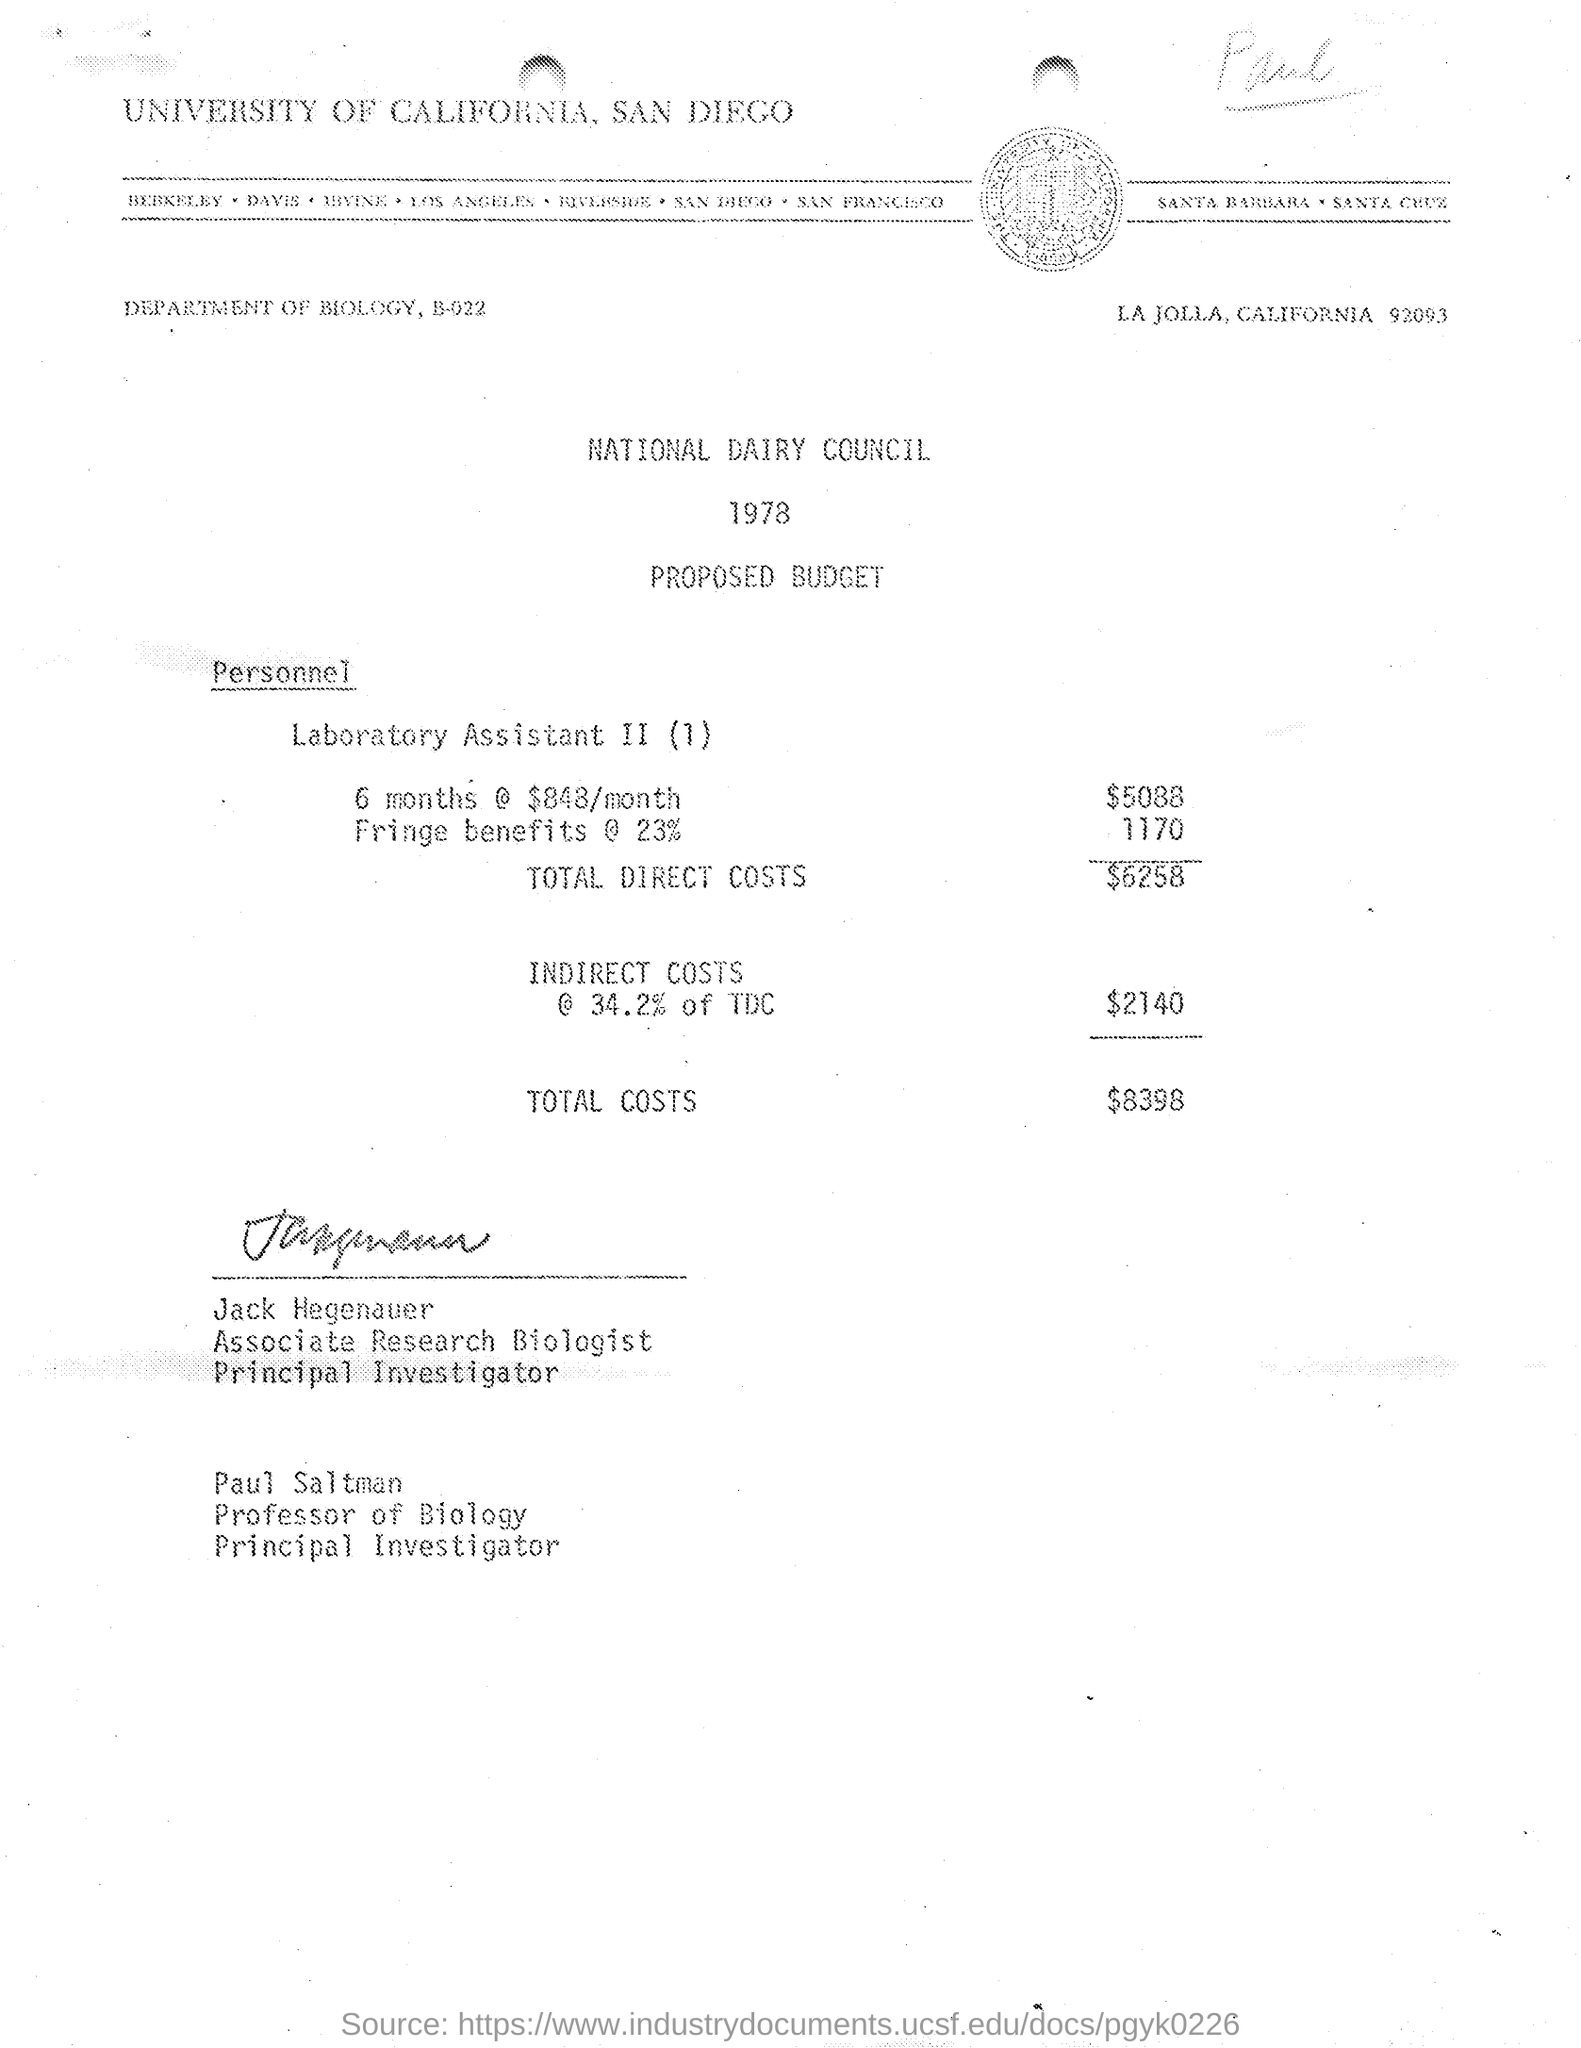What year is this budget proposal for, and which organization has prepared it? The budget proposal is for the year 1978, and it has been prepared for the National Dairy Council by the Department of Biology at the University of California, San Diego. 